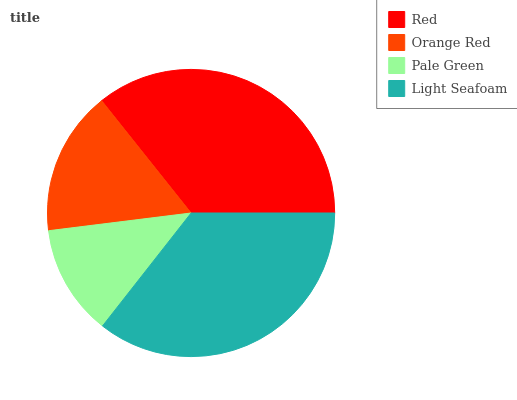Is Pale Green the minimum?
Answer yes or no. Yes. Is Red the maximum?
Answer yes or no. Yes. Is Orange Red the minimum?
Answer yes or no. No. Is Orange Red the maximum?
Answer yes or no. No. Is Red greater than Orange Red?
Answer yes or no. Yes. Is Orange Red less than Red?
Answer yes or no. Yes. Is Orange Red greater than Red?
Answer yes or no. No. Is Red less than Orange Red?
Answer yes or no. No. Is Light Seafoam the high median?
Answer yes or no. Yes. Is Orange Red the low median?
Answer yes or no. Yes. Is Red the high median?
Answer yes or no. No. Is Light Seafoam the low median?
Answer yes or no. No. 